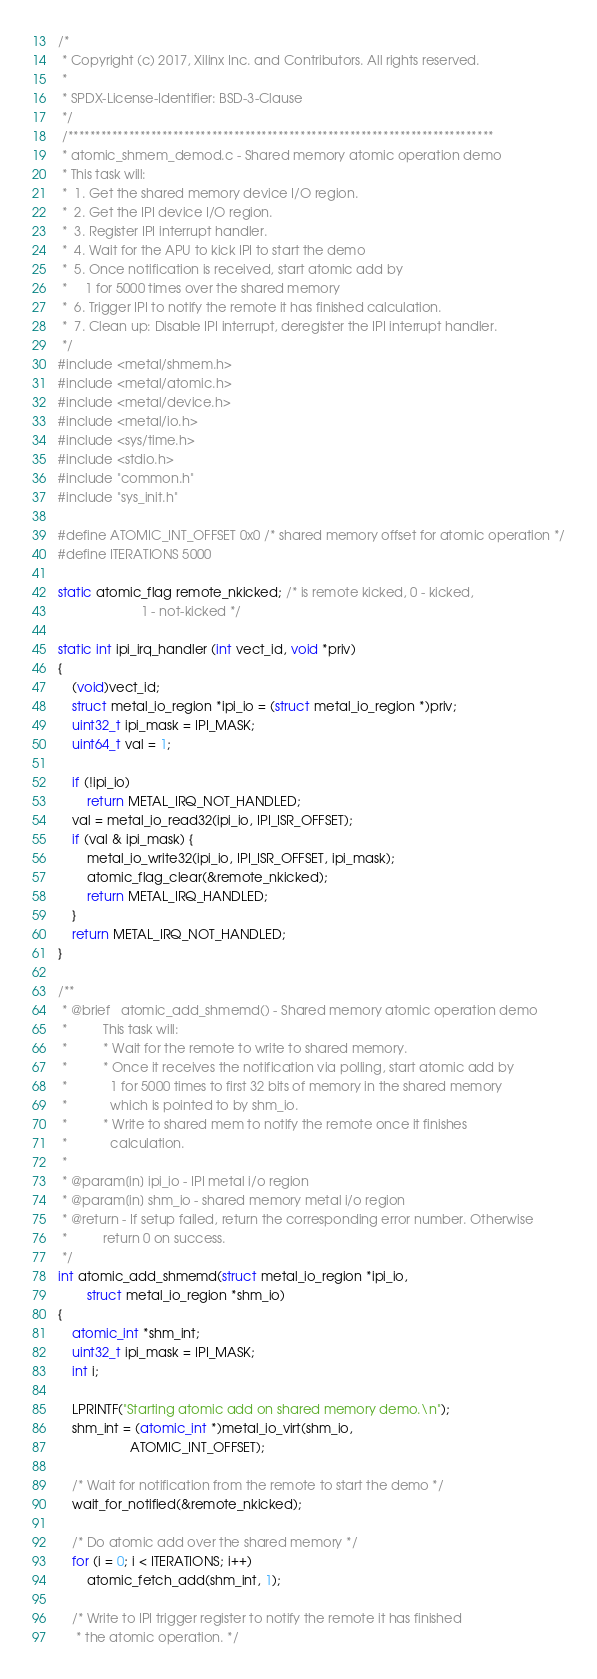Convert code to text. <code><loc_0><loc_0><loc_500><loc_500><_C_>/*
 * Copyright (c) 2017, Xilinx Inc. and Contributors. All rights reserved.
 *
 * SPDX-License-Identifier: BSD-3-Clause
 */
 /*****************************************************************************
 * atomic_shmem_demod.c - Shared memory atomic operation demo
 * This task will:
 *  1. Get the shared memory device I/O region.
 *  2. Get the IPI device I/O region.
 *  3. Register IPI interrupt handler.
 *  4. Wait for the APU to kick IPI to start the demo
 *  5. Once notification is received, start atomic add by
 *     1 for 5000 times over the shared memory
 *  6. Trigger IPI to notify the remote it has finished calculation.
 *  7. Clean up: Disable IPI interrupt, deregister the IPI interrupt handler.
 */
#include <metal/shmem.h>
#include <metal/atomic.h>
#include <metal/device.h>
#include <metal/io.h>
#include <sys/time.h>
#include <stdio.h>
#include "common.h"
#include "sys_init.h"

#define ATOMIC_INT_OFFSET 0x0 /* shared memory offset for atomic operation */
#define ITERATIONS 5000

static atomic_flag remote_nkicked; /* is remote kicked, 0 - kicked,
				       1 - not-kicked */

static int ipi_irq_handler (int vect_id, void *priv)
{
	(void)vect_id;
	struct metal_io_region *ipi_io = (struct metal_io_region *)priv;
	uint32_t ipi_mask = IPI_MASK;
	uint64_t val = 1;

	if (!ipi_io)
		return METAL_IRQ_NOT_HANDLED;
	val = metal_io_read32(ipi_io, IPI_ISR_OFFSET);
	if (val & ipi_mask) {
		metal_io_write32(ipi_io, IPI_ISR_OFFSET, ipi_mask);
		atomic_flag_clear(&remote_nkicked);
		return METAL_IRQ_HANDLED;
	}
	return METAL_IRQ_NOT_HANDLED;
}

/**
 * @brief   atomic_add_shmemd() - Shared memory atomic operation demo
 *          This task will:
 *          * Wait for the remote to write to shared memory.
 *          * Once it receives the notification via polling, start atomic add by
 *            1 for 5000 times to first 32 bits of memory in the shared memory
 *            which is pointed to by shm_io.
 *          * Write to shared mem to notify the remote once it finishes
 *            calculation.
 *
 * @param[in] ipi_io - IPI metal i/o region
 * @param[in] shm_io - shared memory metal i/o region
 * @return - If setup failed, return the corresponding error number. Otherwise
 *          return 0 on success.
 */
int atomic_add_shmemd(struct metal_io_region *ipi_io,
		struct metal_io_region *shm_io)
{
	atomic_int *shm_int;
	uint32_t ipi_mask = IPI_MASK;
	int i;

	LPRINTF("Starting atomic add on shared memory demo.\n");
	shm_int = (atomic_int *)metal_io_virt(shm_io,
					ATOMIC_INT_OFFSET);

	/* Wait for notification from the remote to start the demo */
	wait_for_notified(&remote_nkicked);

	/* Do atomic add over the shared memory */
	for (i = 0; i < ITERATIONS; i++)
		atomic_fetch_add(shm_int, 1);

	/* Write to IPI trigger register to notify the remote it has finished
	 * the atomic operation. */</code> 